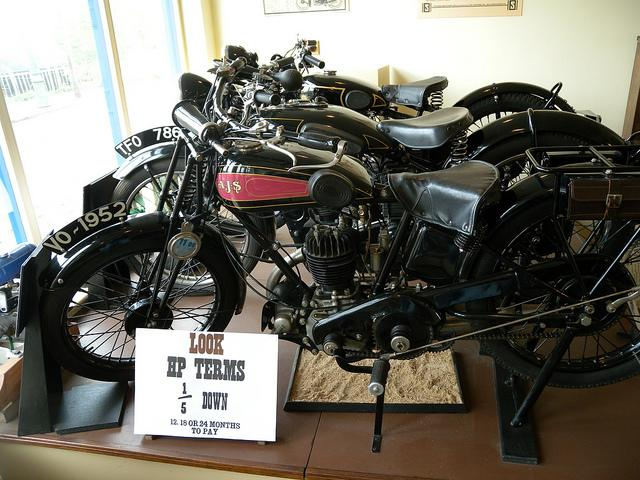What are the terms referring to? payment 